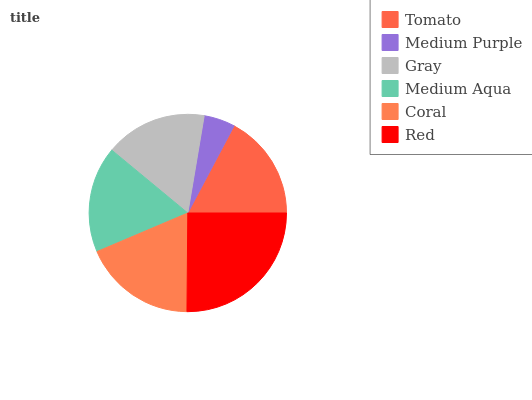Is Medium Purple the minimum?
Answer yes or no. Yes. Is Red the maximum?
Answer yes or no. Yes. Is Gray the minimum?
Answer yes or no. No. Is Gray the maximum?
Answer yes or no. No. Is Gray greater than Medium Purple?
Answer yes or no. Yes. Is Medium Purple less than Gray?
Answer yes or no. Yes. Is Medium Purple greater than Gray?
Answer yes or no. No. Is Gray less than Medium Purple?
Answer yes or no. No. Is Medium Aqua the high median?
Answer yes or no. Yes. Is Tomato the low median?
Answer yes or no. Yes. Is Gray the high median?
Answer yes or no. No. Is Coral the low median?
Answer yes or no. No. 